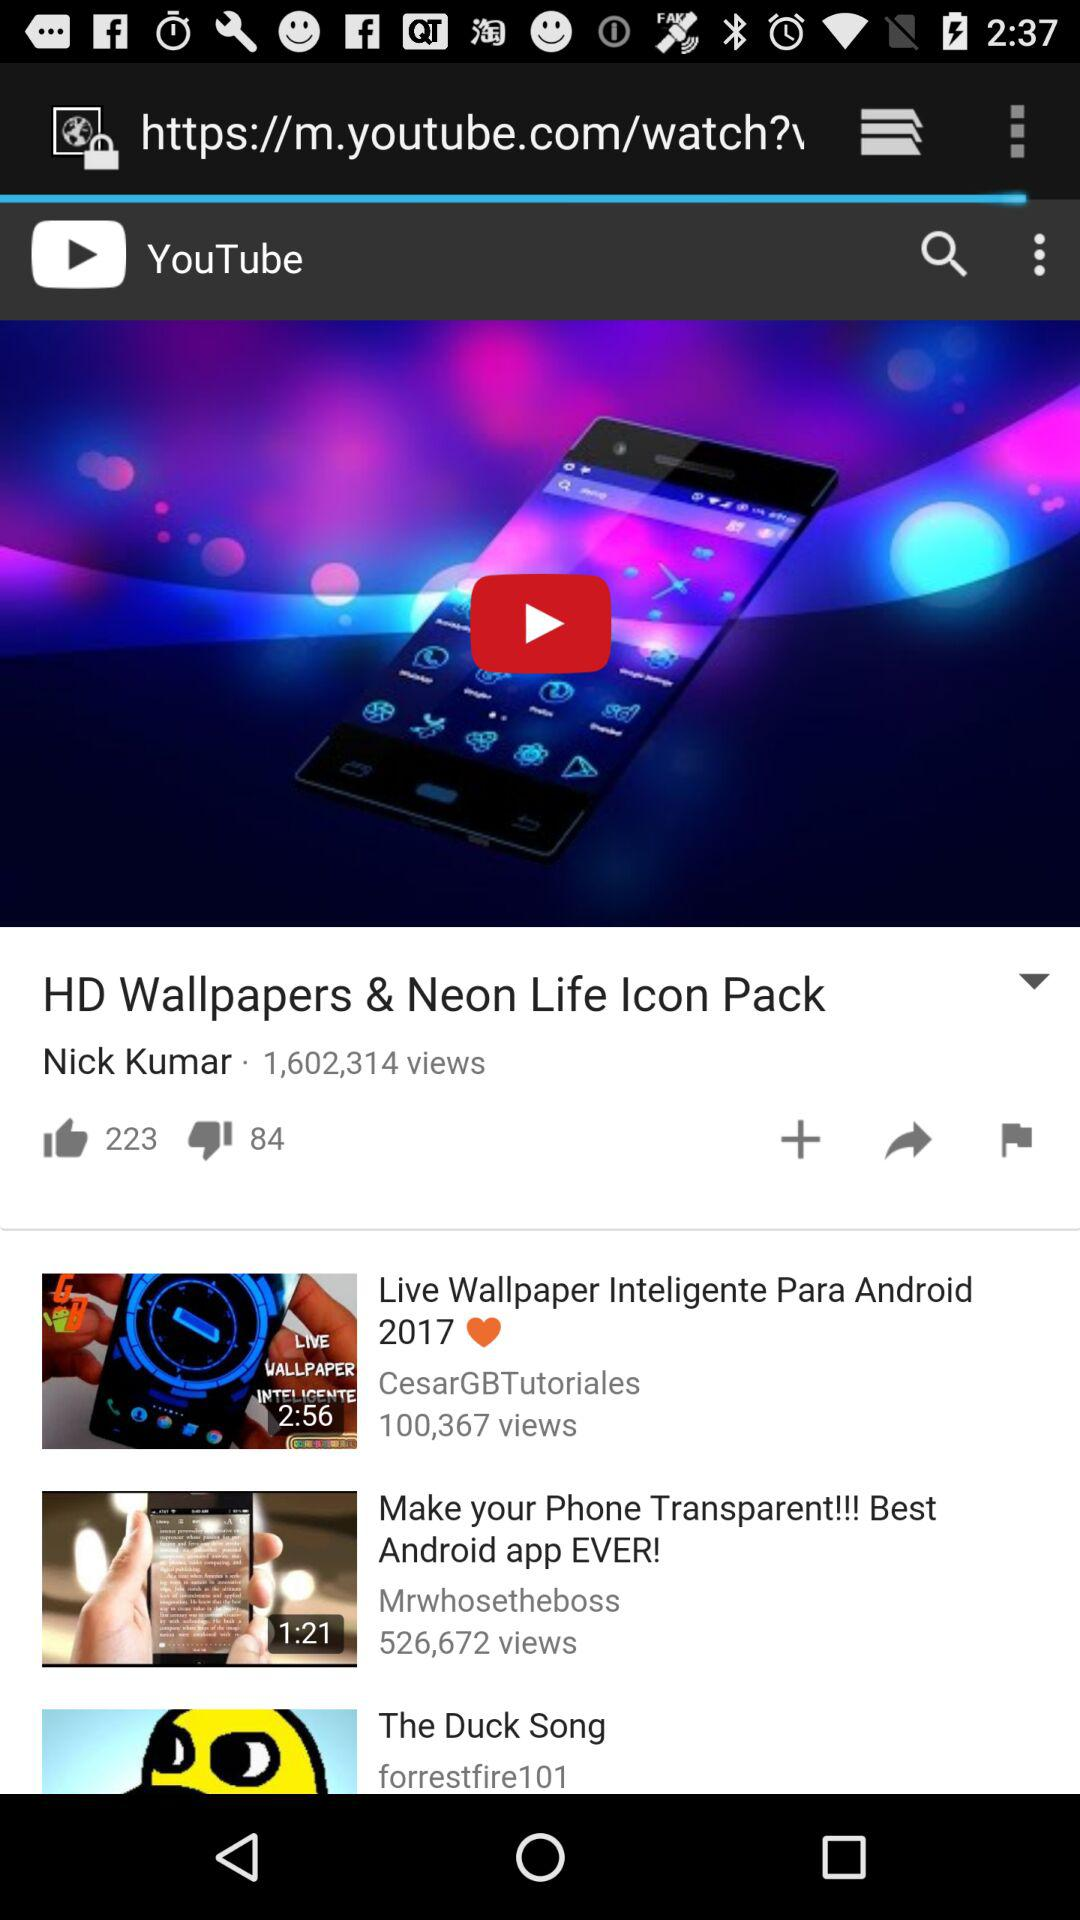How many likes are there? There are 223 likes. 